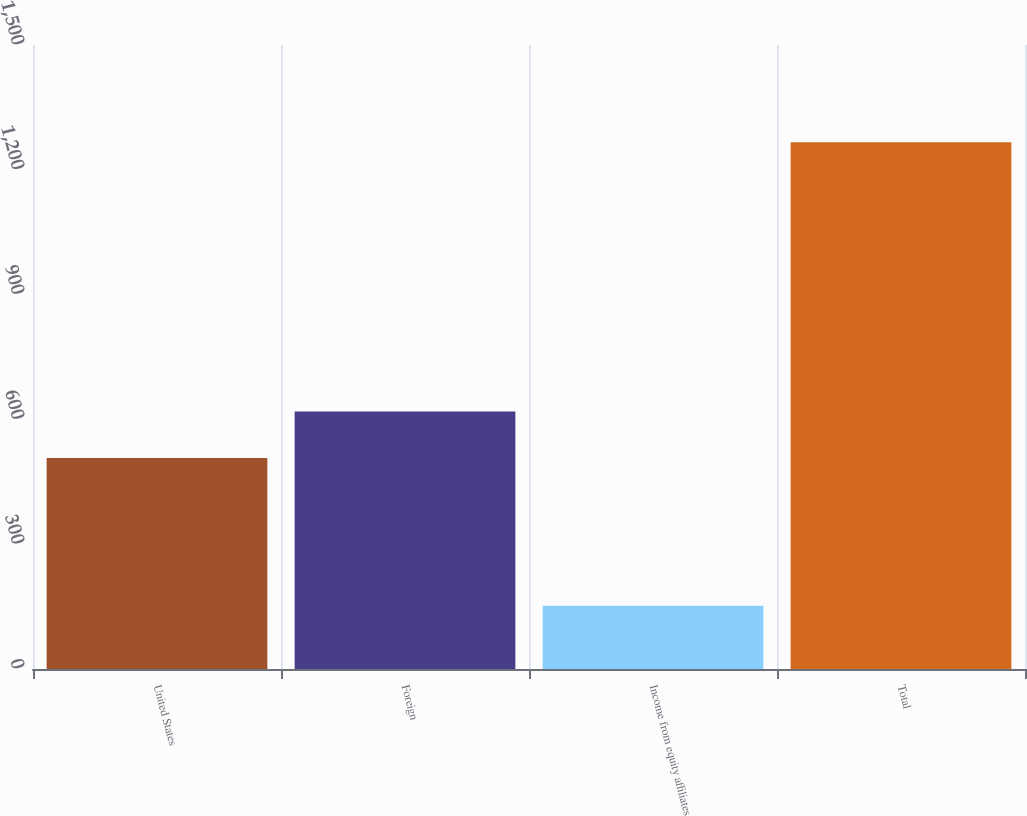Convert chart. <chart><loc_0><loc_0><loc_500><loc_500><bar_chart><fcel>United States<fcel>Foreign<fcel>Income from equity affiliates<fcel>Total<nl><fcel>507.5<fcel>618.88<fcel>152.3<fcel>1266.1<nl></chart> 